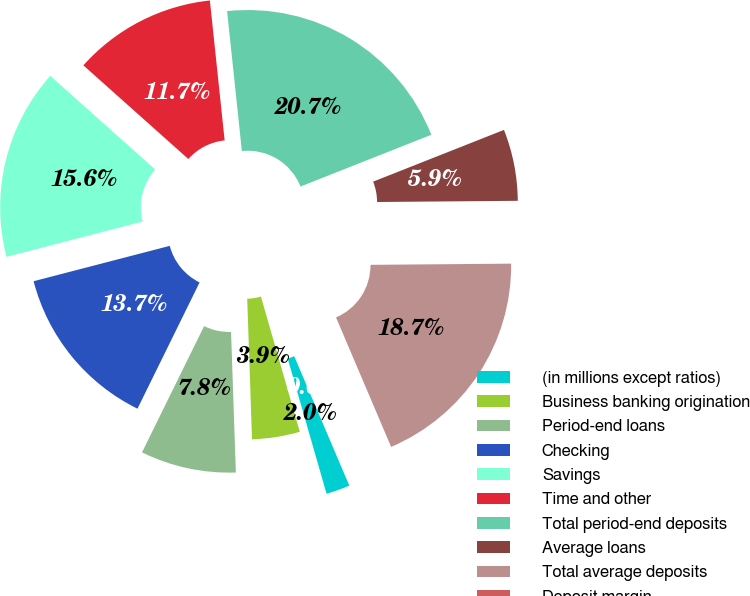Convert chart to OTSL. <chart><loc_0><loc_0><loc_500><loc_500><pie_chart><fcel>(in millions except ratios)<fcel>Business banking origination<fcel>Period-end loans<fcel>Checking<fcel>Savings<fcel>Time and other<fcel>Total period-end deposits<fcel>Average loans<fcel>Total average deposits<fcel>Deposit margin<nl><fcel>1.95%<fcel>3.91%<fcel>7.82%<fcel>13.68%<fcel>15.64%<fcel>11.73%<fcel>20.68%<fcel>5.86%<fcel>18.73%<fcel>0.0%<nl></chart> 